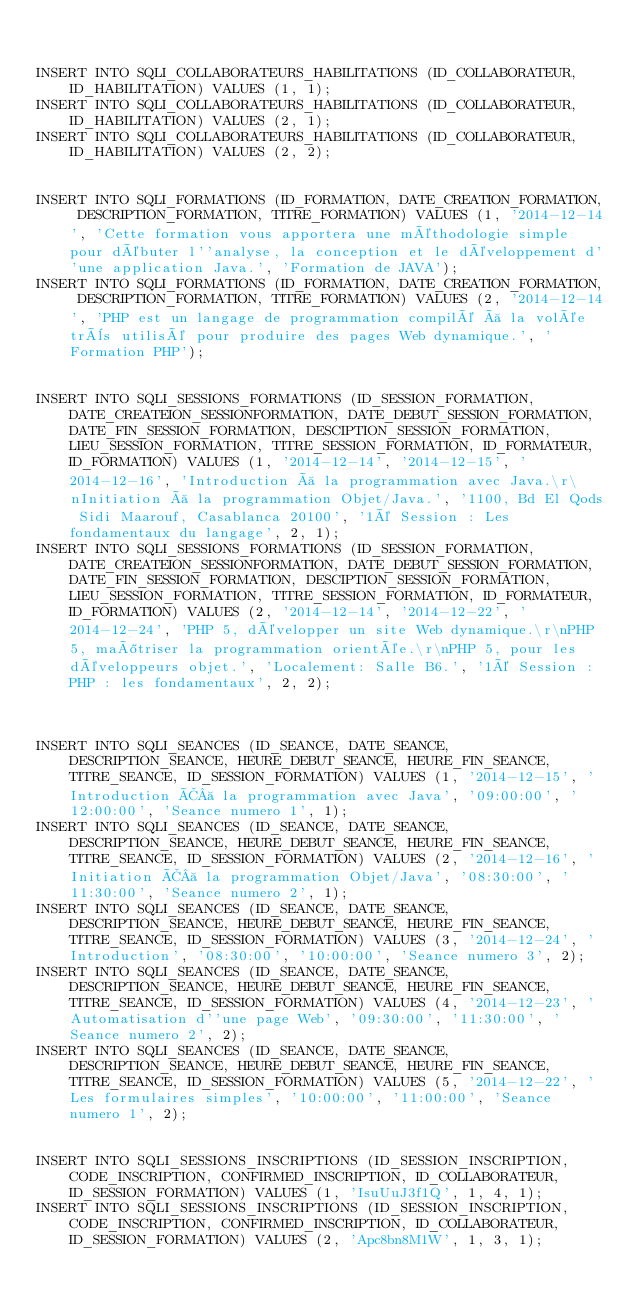<code> <loc_0><loc_0><loc_500><loc_500><_SQL_>

INSERT INTO SQLI_COLLABORATEURS_HABILITATIONS (ID_COLLABORATEUR, ID_HABILITATION) VALUES (1, 1);
INSERT INTO SQLI_COLLABORATEURS_HABILITATIONS (ID_COLLABORATEUR, ID_HABILITATION) VALUES (2, 1);
INSERT INTO SQLI_COLLABORATEURS_HABILITATIONS (ID_COLLABORATEUR, ID_HABILITATION) VALUES (2, 2);


INSERT INTO SQLI_FORMATIONS (ID_FORMATION, DATE_CREATION_FORMATION, DESCRIPTION_FORMATION, TITRE_FORMATION) VALUES (1, '2014-12-14', 'Cette formation vous apportera une méthodologie simple pour débuter l''analyse, la conception et le développement d''une application Java.', 'Formation de JAVA');
INSERT INTO SQLI_FORMATIONS (ID_FORMATION, DATE_CREATION_FORMATION, DESCRIPTION_FORMATION, TITRE_FORMATION) VALUES (2, '2014-12-14', 'PHP est un langage de programmation compilé à la volée très utilisé pour produire des pages Web dynamique.', 'Formation PHP');


INSERT INTO SQLI_SESSIONS_FORMATIONS (ID_SESSION_FORMATION, DATE_CREATEION_SESSIONFORMATION, DATE_DEBUT_SESSION_FORMATION, DATE_FIN_SESSION_FORMATION, DESCIPTION_SESSION_FORMATION, LIEU_SESSION_FORMATION, TITRE_SESSION_FORMATION, ID_FORMATEUR, ID_FORMATION) VALUES (1, '2014-12-14', '2014-12-15', '2014-12-16', 'Introduction à la programmation avec Java.\r\nInitiation à la programmation Objet/Java.', '1100, Bd El Qods Sidi Maarouf, Casablanca 20100', '1é Session : Les fondamentaux du langage', 2, 1);
INSERT INTO SQLI_SESSIONS_FORMATIONS (ID_SESSION_FORMATION, DATE_CREATEION_SESSIONFORMATION, DATE_DEBUT_SESSION_FORMATION, DATE_FIN_SESSION_FORMATION, DESCIPTION_SESSION_FORMATION, LIEU_SESSION_FORMATION, TITRE_SESSION_FORMATION, ID_FORMATEUR, ID_FORMATION) VALUES (2, '2014-12-14', '2014-12-22', '2014-12-24', 'PHP 5, développer un site Web dynamique.\r\nPHP 5, maîtriser la programmation orientée.\r\nPHP 5, pour les développeurs objet.', 'Localement: Salle B6.', '1é Session : PHP : les fondamentaux', 2, 2);



INSERT INTO SQLI_SEANCES (ID_SEANCE, DATE_SEANCE, DESCRIPTION_SEANCE, HEURE_DEBUT_SEANCE, HEURE_FIN_SEANCE, TITRE_SEANCE, ID_SESSION_FORMATION) VALUES (1, '2014-12-15', 'Introduction Ã  la programmation avec Java', '09:00:00', '12:00:00', 'Seance numero 1', 1);
INSERT INTO SQLI_SEANCES (ID_SEANCE, DATE_SEANCE, DESCRIPTION_SEANCE, HEURE_DEBUT_SEANCE, HEURE_FIN_SEANCE, TITRE_SEANCE, ID_SESSION_FORMATION) VALUES (2, '2014-12-16', 'Initiation Ã  la programmation Objet/Java', '08:30:00', '11:30:00', 'Seance numero 2', 1);
INSERT INTO SQLI_SEANCES (ID_SEANCE, DATE_SEANCE, DESCRIPTION_SEANCE, HEURE_DEBUT_SEANCE, HEURE_FIN_SEANCE, TITRE_SEANCE, ID_SESSION_FORMATION) VALUES (3, '2014-12-24', 'Introduction', '08:30:00', '10:00:00', 'Seance numero 3', 2);
INSERT INTO SQLI_SEANCES (ID_SEANCE, DATE_SEANCE, DESCRIPTION_SEANCE, HEURE_DEBUT_SEANCE, HEURE_FIN_SEANCE, TITRE_SEANCE, ID_SESSION_FORMATION) VALUES (4, '2014-12-23', 'Automatisation d''une page Web', '09:30:00', '11:30:00', 'Seance numero 2', 2);
INSERT INTO SQLI_SEANCES (ID_SEANCE, DATE_SEANCE, DESCRIPTION_SEANCE, HEURE_DEBUT_SEANCE, HEURE_FIN_SEANCE, TITRE_SEANCE, ID_SESSION_FORMATION) VALUES (5, '2014-12-22', 'Les formulaires simples', '10:00:00', '11:00:00', 'Seance numero 1', 2);


INSERT INTO SQLI_SESSIONS_INSCRIPTIONS (ID_SESSION_INSCRIPTION, CODE_INSCRIPTION, CONFIRMED_INSCRIPTION, ID_COLLABORATEUR, ID_SESSION_FORMATION) VALUES (1, 'IsuUuJ3f1Q', 1, 4, 1);
INSERT INTO SQLI_SESSIONS_INSCRIPTIONS (ID_SESSION_INSCRIPTION, CODE_INSCRIPTION, CONFIRMED_INSCRIPTION, ID_COLLABORATEUR, ID_SESSION_FORMATION) VALUES (2, 'Apc8bn8M1W', 1, 3, 1);</code> 